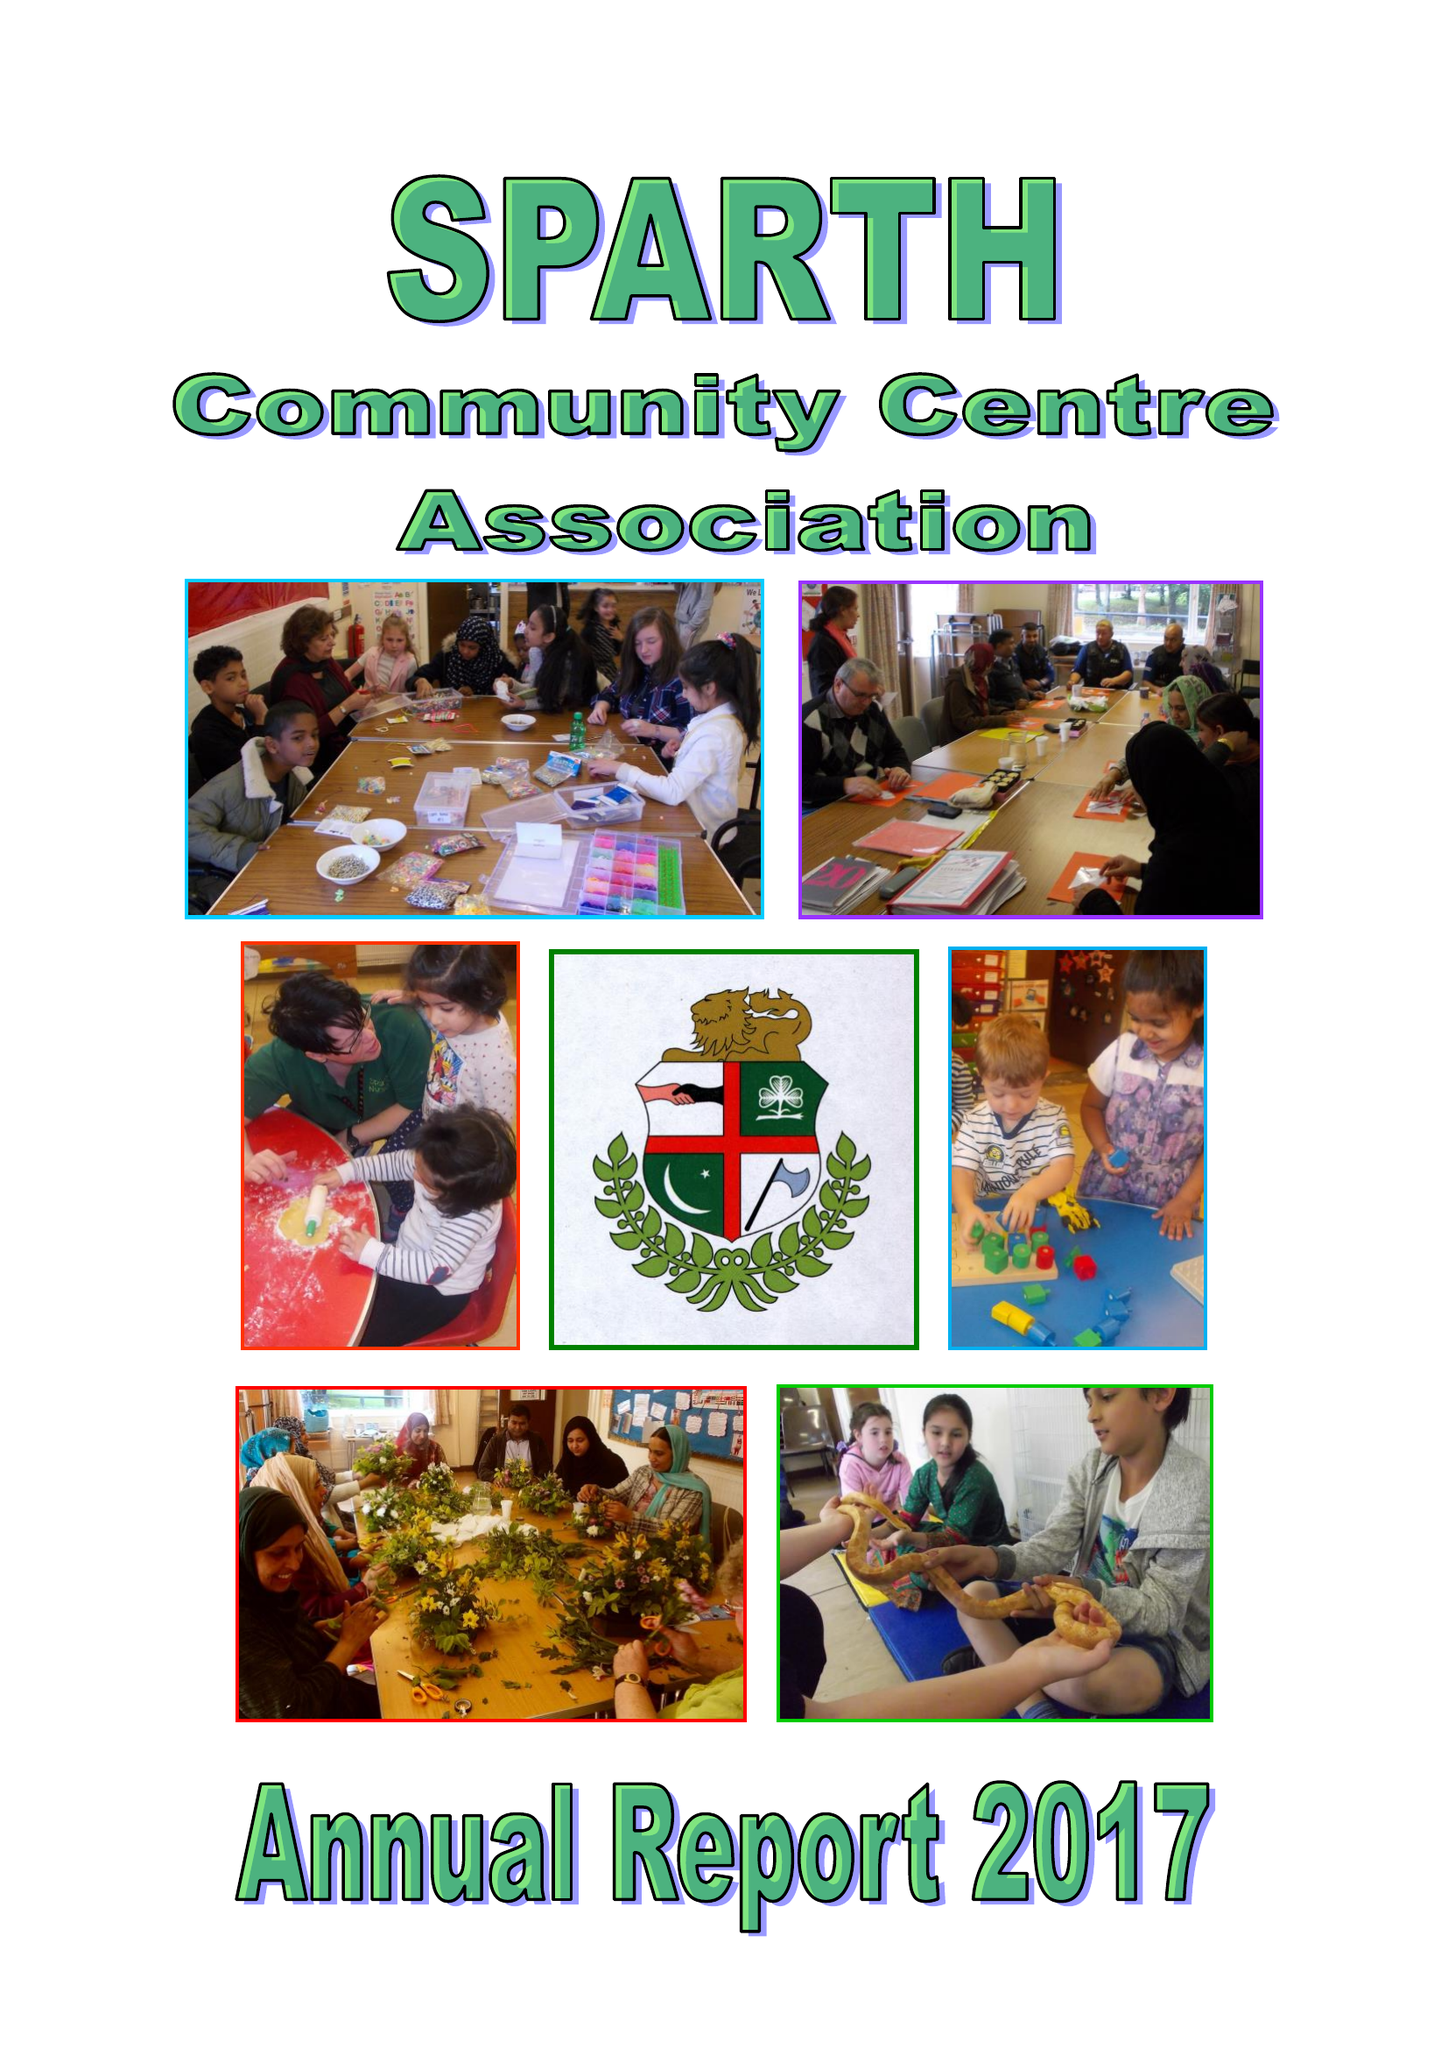What is the value for the address__post_town?
Answer the question using a single word or phrase. ROCHDALE 